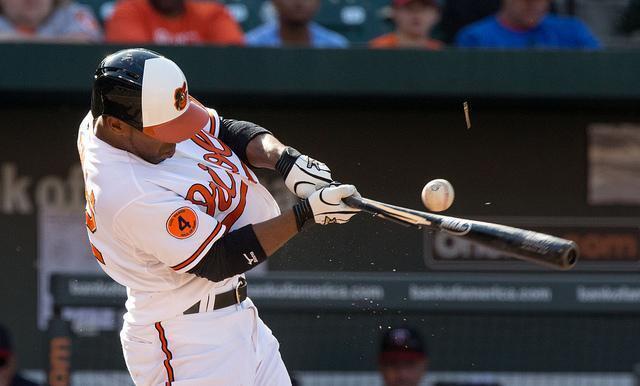Who got this ball to this place?
Make your selection from the four choices given to correctly answer the question.
Options: Catcher, pitcher, outfielder, coach. Pitcher. 